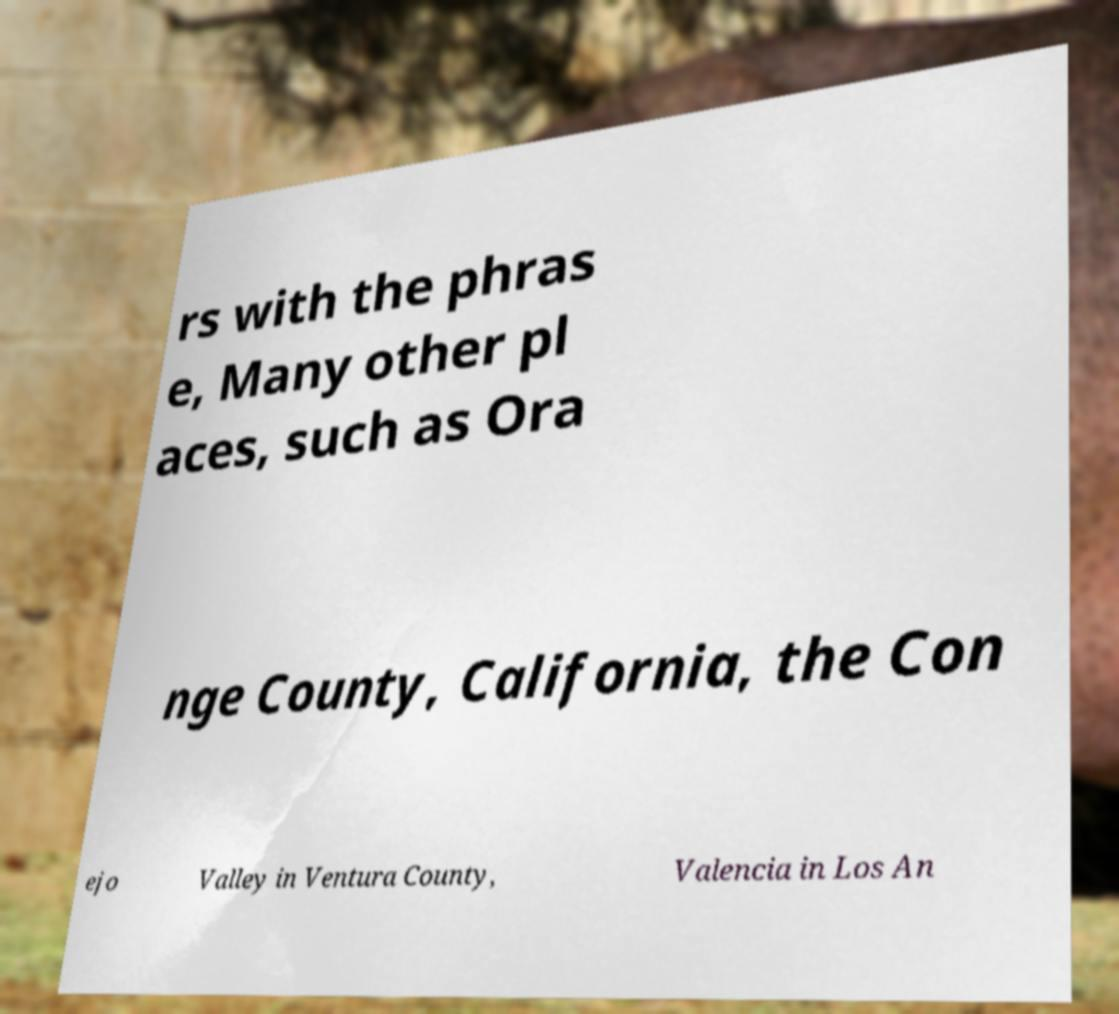What messages or text are displayed in this image? I need them in a readable, typed format. rs with the phras e, Many other pl aces, such as Ora nge County, California, the Con ejo Valley in Ventura County, Valencia in Los An 